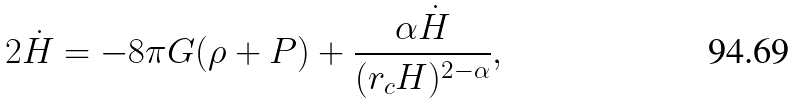<formula> <loc_0><loc_0><loc_500><loc_500>2 \dot { H } = - 8 \pi G ( \rho + P ) + \frac { \alpha \dot { H } } { ( r _ { c } H ) ^ { 2 - \alpha } } ,</formula> 